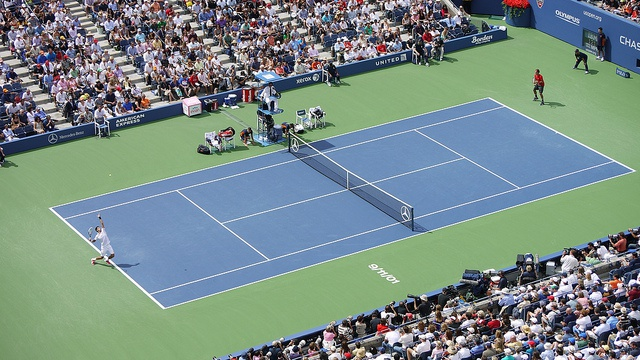Describe the objects in this image and their specific colors. I can see people in gray, black, lightgreen, and darkgray tones, people in gray, lavender, and darkgray tones, people in gray, black, maroon, and darkgray tones, people in gray, black, teal, and lightgreen tones, and chair in gray, darkgray, black, and lightgray tones in this image. 